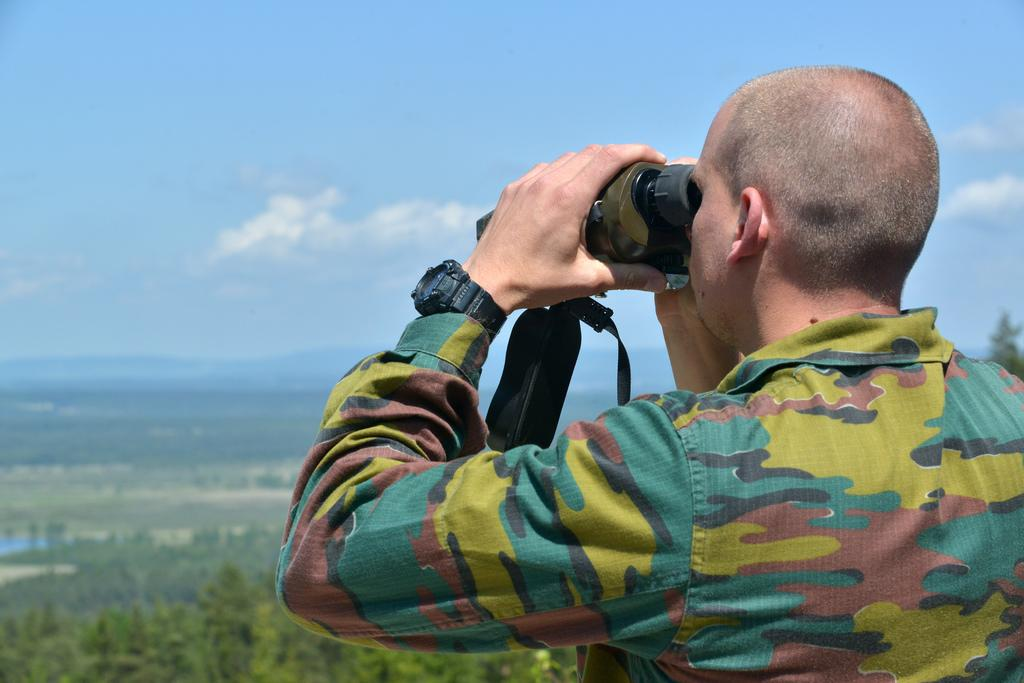Who is present in the image? There is a man in the image. What is the man doing in the image? The man is using a binocular in the image. What can be seen in the background of the image? The sky is visible in the image. What is the condition of the sky in the image? Clouds are present in the sky. What type of jam is being spread on the whip in the image? There is no jam or whip present in the image; it features a man using a binocular and a visible sky with clouds. 